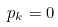<formula> <loc_0><loc_0><loc_500><loc_500>p _ { k } = 0</formula> 